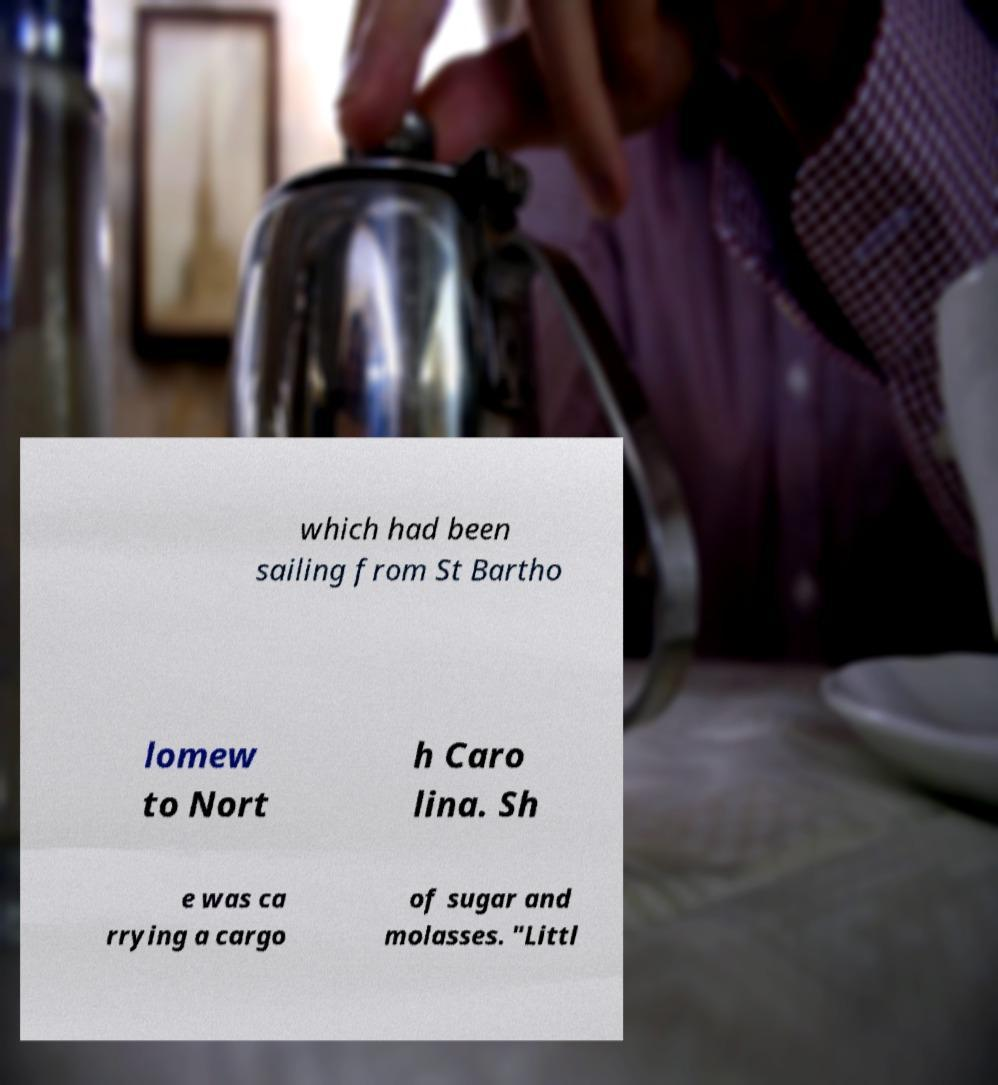Please read and relay the text visible in this image. What does it say? which had been sailing from St Bartho lomew to Nort h Caro lina. Sh e was ca rrying a cargo of sugar and molasses. "Littl 